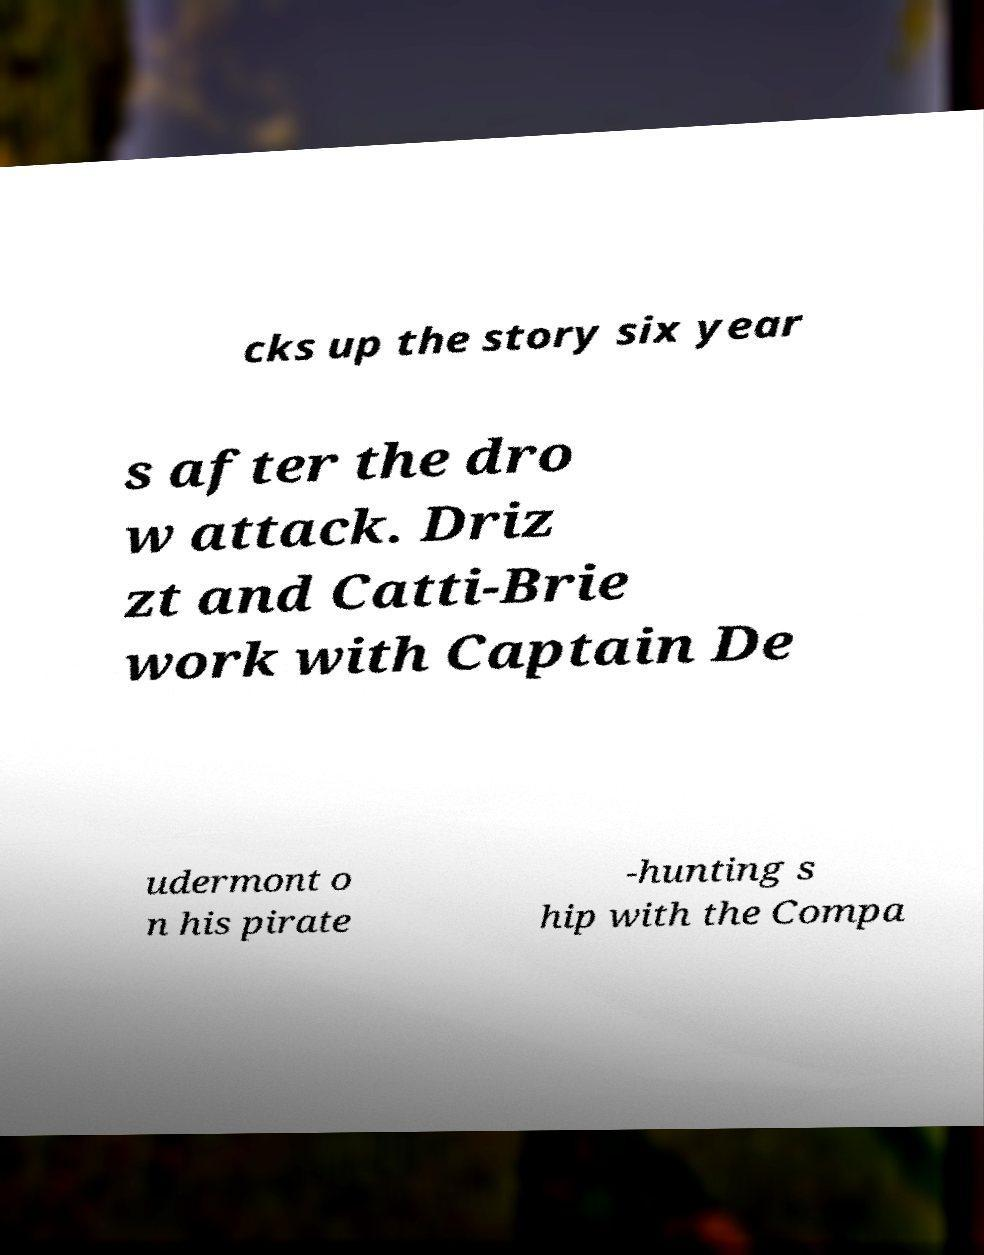There's text embedded in this image that I need extracted. Can you transcribe it verbatim? cks up the story six year s after the dro w attack. Driz zt and Catti-Brie work with Captain De udermont o n his pirate -hunting s hip with the Compa 